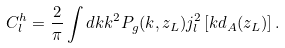Convert formula to latex. <formula><loc_0><loc_0><loc_500><loc_500>C _ { l } ^ { h } = \frac { 2 } { \pi } \int d k k ^ { 2 } P _ { g } ( k , z _ { L } ) j _ { l } ^ { 2 } \left [ k d _ { A } ( z _ { L } ) \right ] .</formula> 